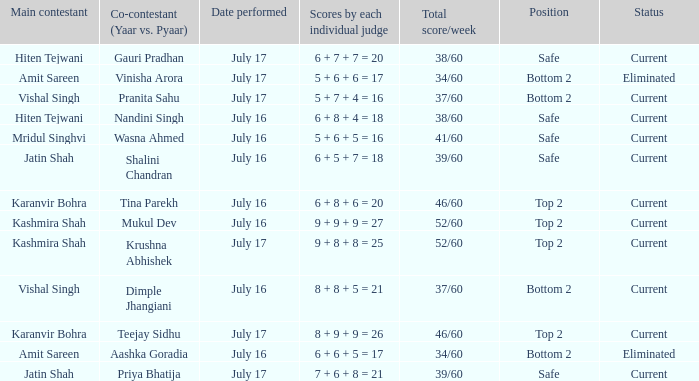What position did the team with the total score of 41/60 get? Safe. 